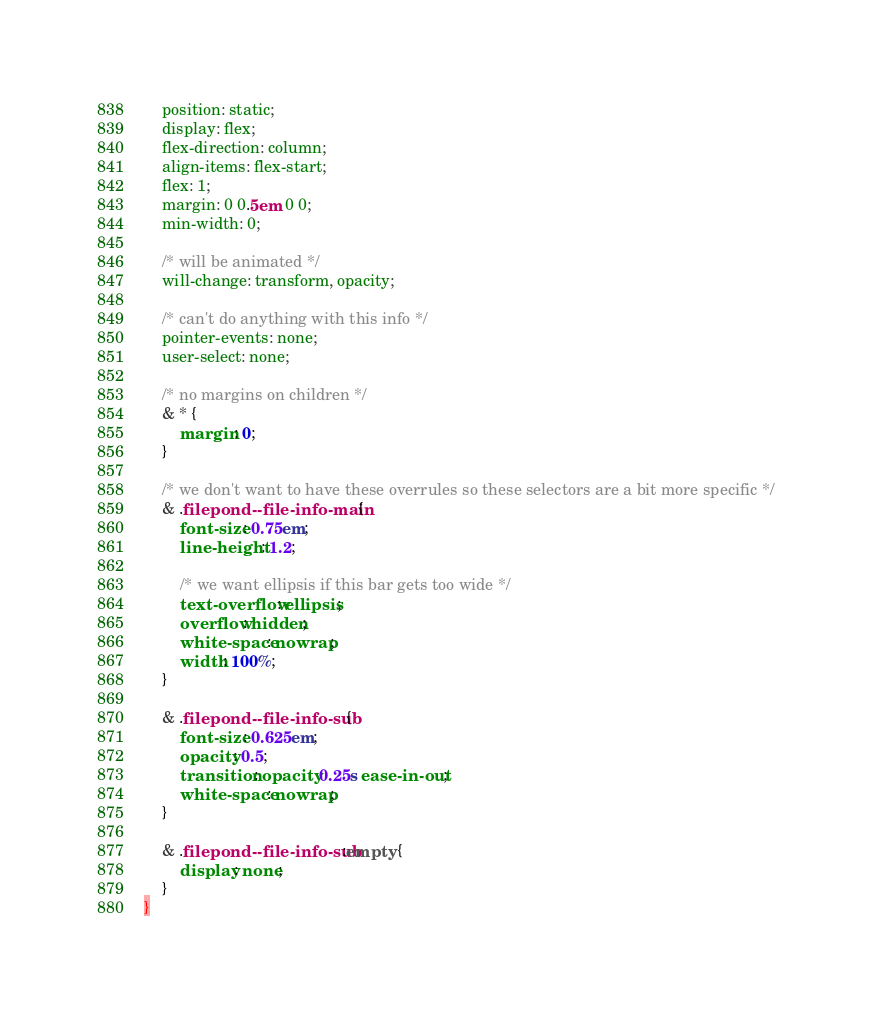<code> <loc_0><loc_0><loc_500><loc_500><_CSS_>    position: static;
    display: flex;
    flex-direction: column;
    align-items: flex-start;
    flex: 1;
    margin: 0 0.5em 0 0;
    min-width: 0;

    /* will be animated */
    will-change: transform, opacity;

    /* can't do anything with this info */
    pointer-events: none;
    user-select: none;

    /* no margins on children */
    & * {
        margin: 0;
    }

    /* we don't want to have these overrules so these selectors are a bit more specific */
    & .filepond--file-info-main {
        font-size: 0.75em;
        line-height: 1.2;

        /* we want ellipsis if this bar gets too wide */
        text-overflow: ellipsis;
        overflow: hidden;
        white-space: nowrap;
        width: 100%;
    }

    & .filepond--file-info-sub {
        font-size: 0.625em;
        opacity: 0.5;
        transition: opacity 0.25s ease-in-out;
        white-space: nowrap;
    }

    & .filepond--file-info-sub:empty {
        display: none;
    }
}
</code> 